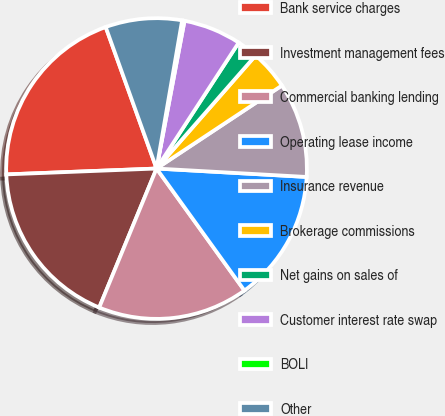<chart> <loc_0><loc_0><loc_500><loc_500><pie_chart><fcel>Bank service charges<fcel>Investment management fees<fcel>Commercial banking lending<fcel>Operating lease income<fcel>Insurance revenue<fcel>Brokerage commissions<fcel>Net gains on sales of<fcel>Customer interest rate swap<fcel>BOLI<fcel>Other<nl><fcel>20.13%<fcel>18.15%<fcel>16.16%<fcel>14.17%<fcel>10.2%<fcel>4.24%<fcel>2.25%<fcel>6.22%<fcel>0.26%<fcel>8.21%<nl></chart> 